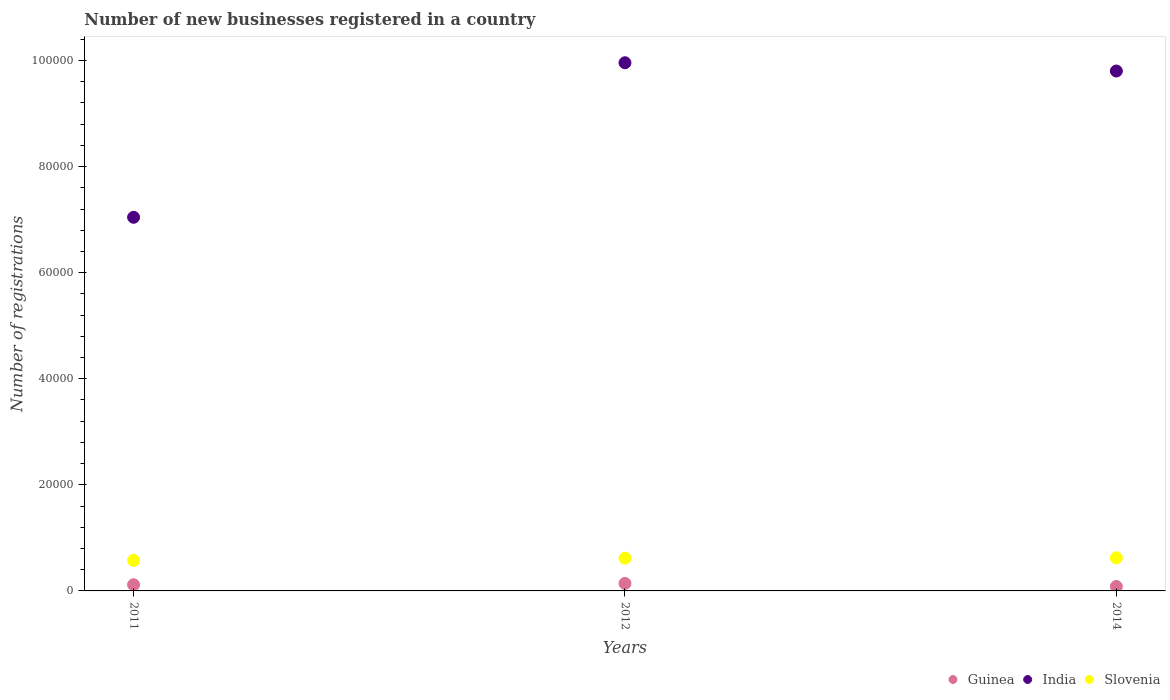Is the number of dotlines equal to the number of legend labels?
Offer a very short reply. Yes. What is the number of new businesses registered in India in 2011?
Ensure brevity in your answer.  7.04e+04. Across all years, what is the maximum number of new businesses registered in India?
Keep it short and to the point. 9.96e+04. Across all years, what is the minimum number of new businesses registered in Guinea?
Give a very brief answer. 839. In which year was the number of new businesses registered in Guinea maximum?
Your answer should be very brief. 2012. In which year was the number of new businesses registered in India minimum?
Offer a terse response. 2011. What is the total number of new businesses registered in India in the graph?
Make the answer very short. 2.68e+05. What is the difference between the number of new businesses registered in India in 2011 and that in 2014?
Offer a terse response. -2.76e+04. What is the difference between the number of new businesses registered in India in 2011 and the number of new businesses registered in Slovenia in 2012?
Your answer should be compact. 6.43e+04. What is the average number of new businesses registered in Slovenia per year?
Offer a very short reply. 6057. In the year 2012, what is the difference between the number of new businesses registered in Slovenia and number of new businesses registered in Guinea?
Give a very brief answer. 4765. In how many years, is the number of new businesses registered in Slovenia greater than 76000?
Provide a succinct answer. 0. What is the ratio of the number of new businesses registered in India in 2012 to that in 2014?
Your answer should be very brief. 1.02. Is the difference between the number of new businesses registered in Slovenia in 2011 and 2014 greater than the difference between the number of new businesses registered in Guinea in 2011 and 2014?
Keep it short and to the point. No. What is the difference between the highest and the second highest number of new businesses registered in India?
Provide a short and direct response. 1558. What is the difference between the highest and the lowest number of new businesses registered in Slovenia?
Ensure brevity in your answer.  489. In how many years, is the number of new businesses registered in Guinea greater than the average number of new businesses registered in Guinea taken over all years?
Keep it short and to the point. 2. Is the sum of the number of new businesses registered in Slovenia in 2012 and 2014 greater than the maximum number of new businesses registered in India across all years?
Make the answer very short. No. Does the number of new businesses registered in Guinea monotonically increase over the years?
Keep it short and to the point. No. Is the number of new businesses registered in Slovenia strictly greater than the number of new businesses registered in Guinea over the years?
Your answer should be very brief. Yes. Is the number of new businesses registered in India strictly less than the number of new businesses registered in Guinea over the years?
Offer a terse response. No. How many dotlines are there?
Provide a short and direct response. 3. How many years are there in the graph?
Offer a very short reply. 3. What is the difference between two consecutive major ticks on the Y-axis?
Offer a very short reply. 2.00e+04. Are the values on the major ticks of Y-axis written in scientific E-notation?
Give a very brief answer. No. How are the legend labels stacked?
Ensure brevity in your answer.  Horizontal. What is the title of the graph?
Offer a very short reply. Number of new businesses registered in a country. Does "Bolivia" appear as one of the legend labels in the graph?
Provide a succinct answer. No. What is the label or title of the X-axis?
Keep it short and to the point. Years. What is the label or title of the Y-axis?
Keep it short and to the point. Number of registrations. What is the Number of registrations of Guinea in 2011?
Your answer should be very brief. 1167. What is the Number of registrations of India in 2011?
Give a very brief answer. 7.04e+04. What is the Number of registrations of Slovenia in 2011?
Offer a very short reply. 5754. What is the Number of registrations in Guinea in 2012?
Offer a very short reply. 1409. What is the Number of registrations in India in 2012?
Offer a very short reply. 9.96e+04. What is the Number of registrations of Slovenia in 2012?
Make the answer very short. 6174. What is the Number of registrations in Guinea in 2014?
Provide a succinct answer. 839. What is the Number of registrations of India in 2014?
Ensure brevity in your answer.  9.80e+04. What is the Number of registrations in Slovenia in 2014?
Provide a succinct answer. 6243. Across all years, what is the maximum Number of registrations of Guinea?
Your answer should be compact. 1409. Across all years, what is the maximum Number of registrations of India?
Offer a terse response. 9.96e+04. Across all years, what is the maximum Number of registrations of Slovenia?
Offer a very short reply. 6243. Across all years, what is the minimum Number of registrations of Guinea?
Provide a short and direct response. 839. Across all years, what is the minimum Number of registrations in India?
Offer a very short reply. 7.04e+04. Across all years, what is the minimum Number of registrations of Slovenia?
Keep it short and to the point. 5754. What is the total Number of registrations in Guinea in the graph?
Offer a very short reply. 3415. What is the total Number of registrations in India in the graph?
Give a very brief answer. 2.68e+05. What is the total Number of registrations of Slovenia in the graph?
Give a very brief answer. 1.82e+04. What is the difference between the Number of registrations of Guinea in 2011 and that in 2012?
Provide a short and direct response. -242. What is the difference between the Number of registrations in India in 2011 and that in 2012?
Your answer should be very brief. -2.91e+04. What is the difference between the Number of registrations of Slovenia in 2011 and that in 2012?
Your answer should be very brief. -420. What is the difference between the Number of registrations of Guinea in 2011 and that in 2014?
Provide a succinct answer. 328. What is the difference between the Number of registrations in India in 2011 and that in 2014?
Keep it short and to the point. -2.76e+04. What is the difference between the Number of registrations in Slovenia in 2011 and that in 2014?
Your answer should be compact. -489. What is the difference between the Number of registrations in Guinea in 2012 and that in 2014?
Give a very brief answer. 570. What is the difference between the Number of registrations of India in 2012 and that in 2014?
Offer a very short reply. 1558. What is the difference between the Number of registrations of Slovenia in 2012 and that in 2014?
Offer a terse response. -69. What is the difference between the Number of registrations of Guinea in 2011 and the Number of registrations of India in 2012?
Your answer should be compact. -9.84e+04. What is the difference between the Number of registrations of Guinea in 2011 and the Number of registrations of Slovenia in 2012?
Ensure brevity in your answer.  -5007. What is the difference between the Number of registrations of India in 2011 and the Number of registrations of Slovenia in 2012?
Ensure brevity in your answer.  6.43e+04. What is the difference between the Number of registrations of Guinea in 2011 and the Number of registrations of India in 2014?
Your answer should be very brief. -9.69e+04. What is the difference between the Number of registrations of Guinea in 2011 and the Number of registrations of Slovenia in 2014?
Keep it short and to the point. -5076. What is the difference between the Number of registrations of India in 2011 and the Number of registrations of Slovenia in 2014?
Provide a short and direct response. 6.42e+04. What is the difference between the Number of registrations of Guinea in 2012 and the Number of registrations of India in 2014?
Your answer should be very brief. -9.66e+04. What is the difference between the Number of registrations in Guinea in 2012 and the Number of registrations in Slovenia in 2014?
Provide a succinct answer. -4834. What is the difference between the Number of registrations of India in 2012 and the Number of registrations of Slovenia in 2014?
Offer a very short reply. 9.33e+04. What is the average Number of registrations in Guinea per year?
Offer a terse response. 1138.33. What is the average Number of registrations in India per year?
Offer a terse response. 8.94e+04. What is the average Number of registrations of Slovenia per year?
Your answer should be very brief. 6057. In the year 2011, what is the difference between the Number of registrations in Guinea and Number of registrations in India?
Keep it short and to the point. -6.93e+04. In the year 2011, what is the difference between the Number of registrations in Guinea and Number of registrations in Slovenia?
Ensure brevity in your answer.  -4587. In the year 2011, what is the difference between the Number of registrations in India and Number of registrations in Slovenia?
Your answer should be very brief. 6.47e+04. In the year 2012, what is the difference between the Number of registrations of Guinea and Number of registrations of India?
Give a very brief answer. -9.82e+04. In the year 2012, what is the difference between the Number of registrations of Guinea and Number of registrations of Slovenia?
Keep it short and to the point. -4765. In the year 2012, what is the difference between the Number of registrations of India and Number of registrations of Slovenia?
Keep it short and to the point. 9.34e+04. In the year 2014, what is the difference between the Number of registrations of Guinea and Number of registrations of India?
Your response must be concise. -9.72e+04. In the year 2014, what is the difference between the Number of registrations of Guinea and Number of registrations of Slovenia?
Your response must be concise. -5404. In the year 2014, what is the difference between the Number of registrations in India and Number of registrations in Slovenia?
Your answer should be very brief. 9.18e+04. What is the ratio of the Number of registrations in Guinea in 2011 to that in 2012?
Your response must be concise. 0.83. What is the ratio of the Number of registrations in India in 2011 to that in 2012?
Your response must be concise. 0.71. What is the ratio of the Number of registrations of Slovenia in 2011 to that in 2012?
Make the answer very short. 0.93. What is the ratio of the Number of registrations of Guinea in 2011 to that in 2014?
Your answer should be compact. 1.39. What is the ratio of the Number of registrations of India in 2011 to that in 2014?
Offer a very short reply. 0.72. What is the ratio of the Number of registrations in Slovenia in 2011 to that in 2014?
Your answer should be compact. 0.92. What is the ratio of the Number of registrations in Guinea in 2012 to that in 2014?
Your answer should be compact. 1.68. What is the ratio of the Number of registrations in India in 2012 to that in 2014?
Make the answer very short. 1.02. What is the ratio of the Number of registrations of Slovenia in 2012 to that in 2014?
Offer a terse response. 0.99. What is the difference between the highest and the second highest Number of registrations in Guinea?
Your answer should be compact. 242. What is the difference between the highest and the second highest Number of registrations in India?
Your answer should be very brief. 1558. What is the difference between the highest and the lowest Number of registrations of Guinea?
Your response must be concise. 570. What is the difference between the highest and the lowest Number of registrations in India?
Provide a succinct answer. 2.91e+04. What is the difference between the highest and the lowest Number of registrations in Slovenia?
Your answer should be very brief. 489. 